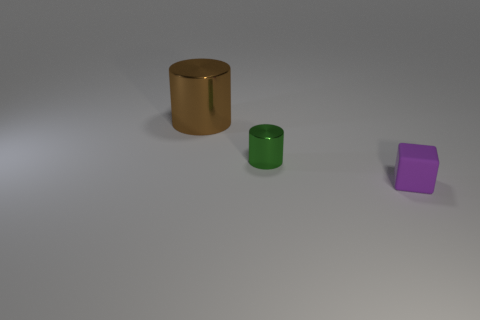Are there fewer small green metallic cylinders that are on the left side of the small green metallic cylinder than large brown metal cylinders to the left of the small purple object?
Your response must be concise. Yes. There is another cylinder that is made of the same material as the big brown cylinder; what is its color?
Keep it short and to the point. Green. There is a small thing to the left of the purple cube; are there any purple matte things left of it?
Provide a short and direct response. No. What is the color of the matte thing that is the same size as the green metal cylinder?
Your answer should be very brief. Purple. What number of things are gray rubber cubes or brown metallic cylinders?
Provide a short and direct response. 1. How big is the cylinder that is in front of the cylinder behind the metallic object in front of the big brown metallic cylinder?
Offer a terse response. Small. What number of small metal cylinders are the same color as the rubber object?
Your response must be concise. 0. How many other brown cylinders are made of the same material as the brown cylinder?
Ensure brevity in your answer.  0. How many objects are either yellow blocks or objects in front of the large metallic thing?
Make the answer very short. 2. What is the color of the small object left of the tiny thing that is in front of the metal object that is in front of the big cylinder?
Provide a short and direct response. Green. 